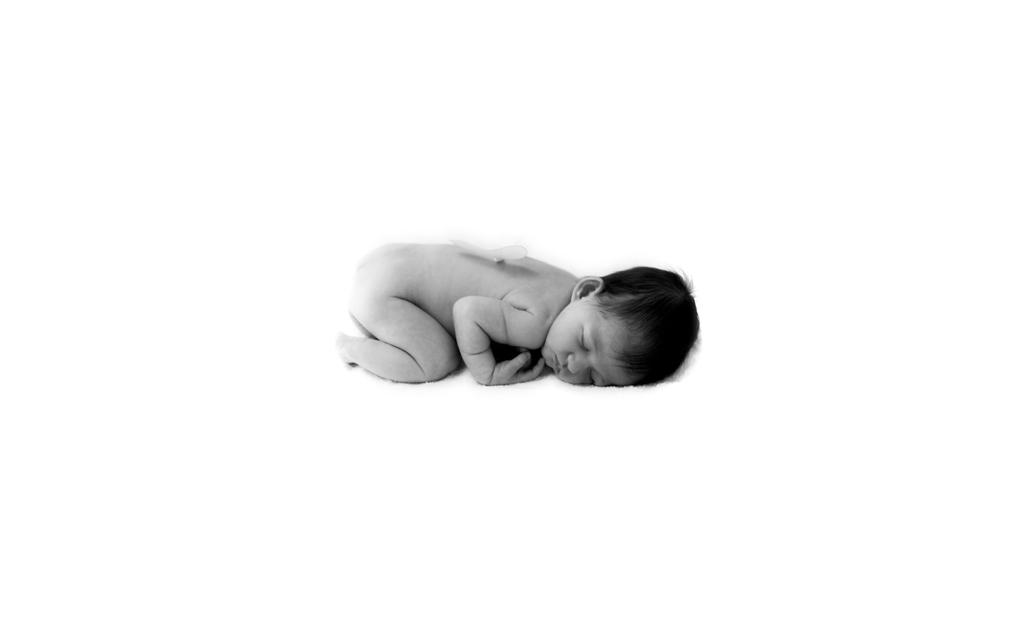What is the main subject of the image? There is a baby in the image. What is the baby doing in the image? The baby is sleeping. What type of wrench is the baby holding in the image? There is no wrench present in the image; the baby is sleeping. Is there any blood visible on the baby in the image? No, there is no blood visible on the baby in the image; the baby is sleeping peacefully. 